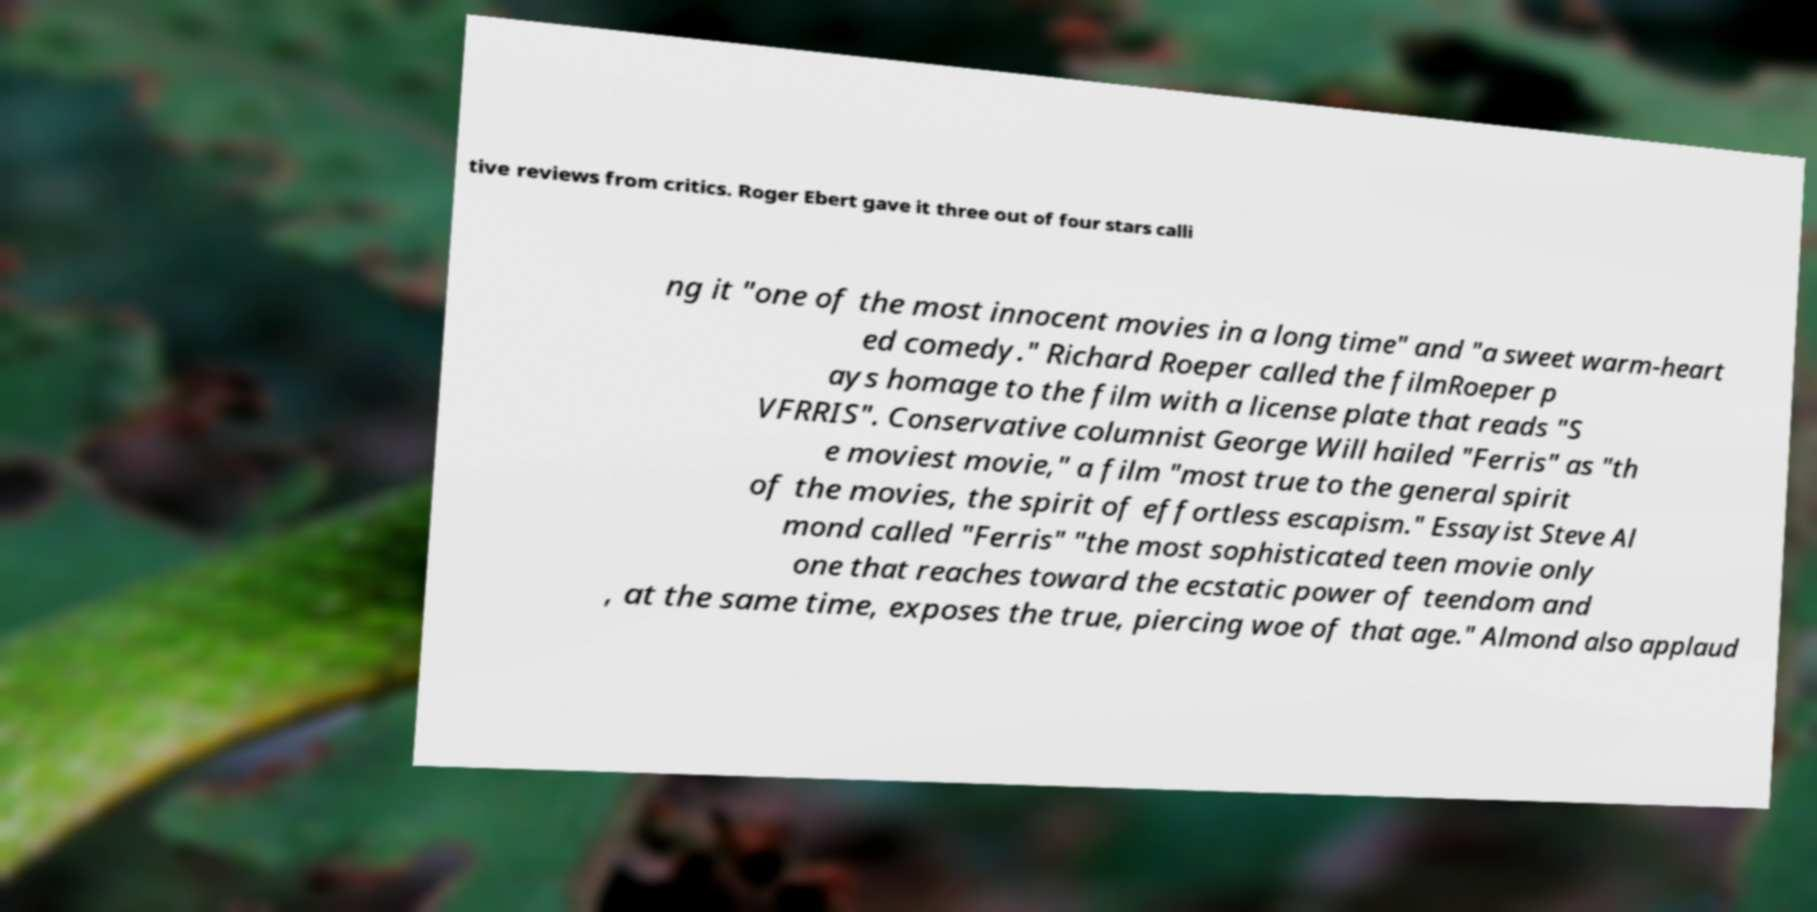Can you accurately transcribe the text from the provided image for me? tive reviews from critics. Roger Ebert gave it three out of four stars calli ng it "one of the most innocent movies in a long time" and "a sweet warm-heart ed comedy." Richard Roeper called the filmRoeper p ays homage to the film with a license plate that reads "S VFRRIS". Conservative columnist George Will hailed "Ferris" as "th e moviest movie," a film "most true to the general spirit of the movies, the spirit of effortless escapism." Essayist Steve Al mond called "Ferris" "the most sophisticated teen movie only one that reaches toward the ecstatic power of teendom and , at the same time, exposes the true, piercing woe of that age." Almond also applaud 